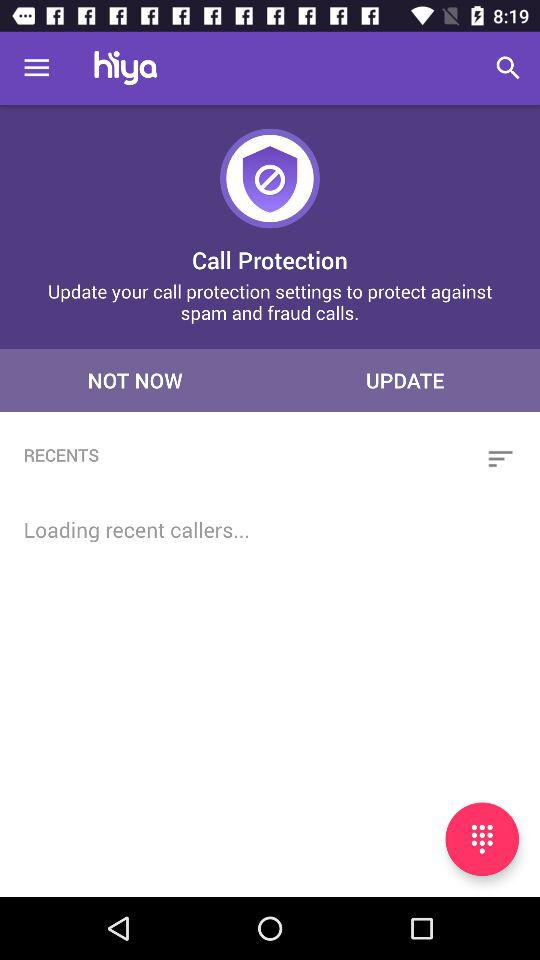What is the application name? The application name is "hiya". 